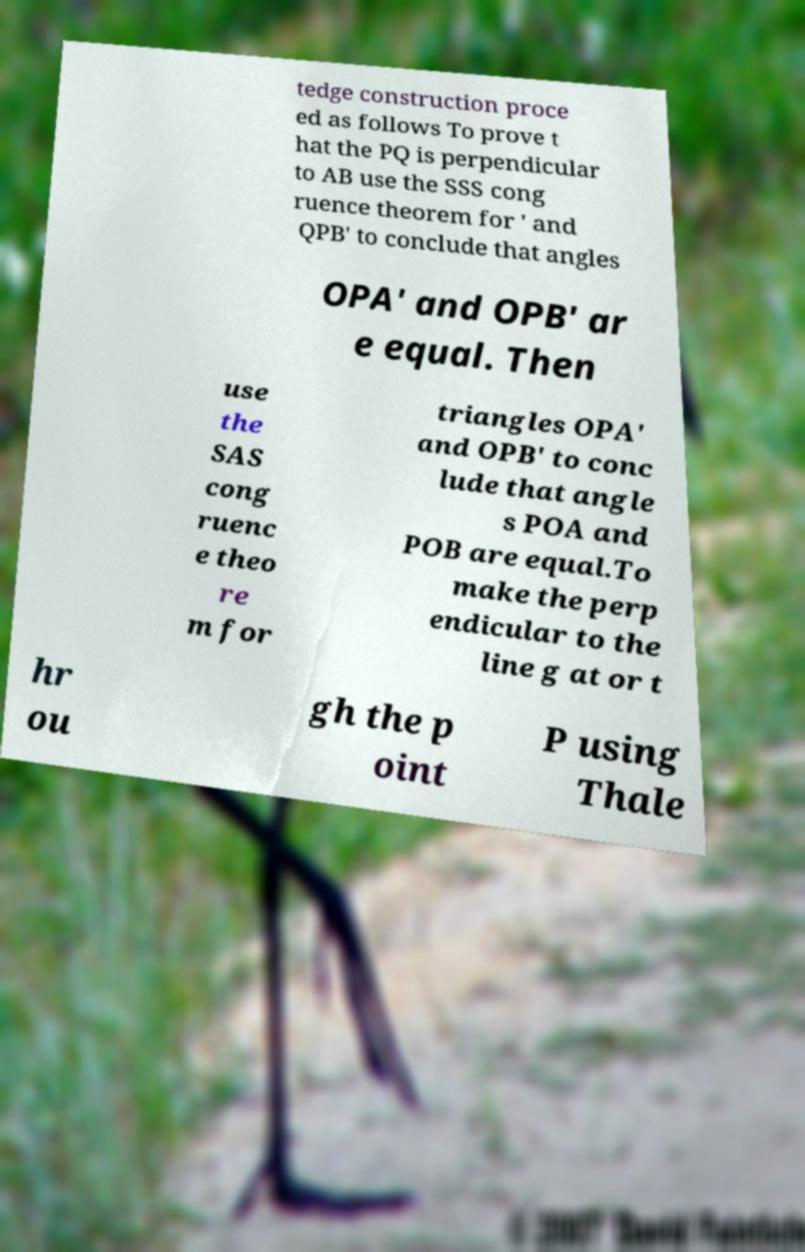Can you accurately transcribe the text from the provided image for me? tedge construction proce ed as follows To prove t hat the PQ is perpendicular to AB use the SSS cong ruence theorem for ' and QPB' to conclude that angles OPA' and OPB' ar e equal. Then use the SAS cong ruenc e theo re m for triangles OPA' and OPB' to conc lude that angle s POA and POB are equal.To make the perp endicular to the line g at or t hr ou gh the p oint P using Thale 